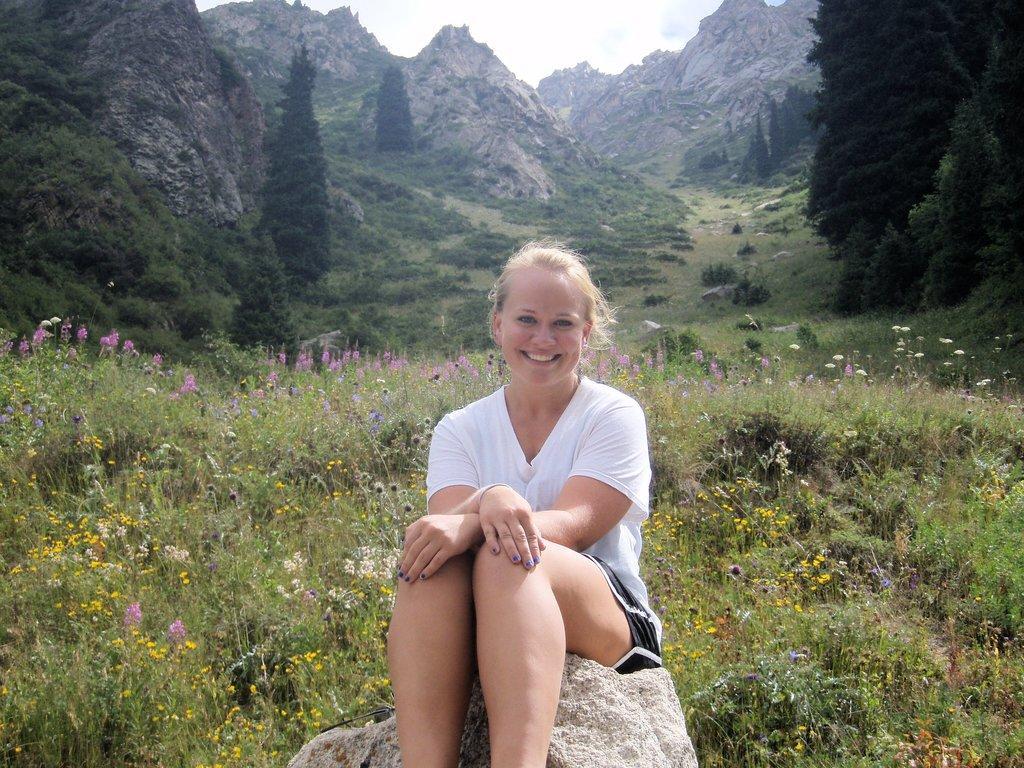Can you describe this image briefly? In the center of the image we can see one woman is sitting on the rock and she is smiling. In the background, we can see the sky, hills, trees and plants with different color flowers. 